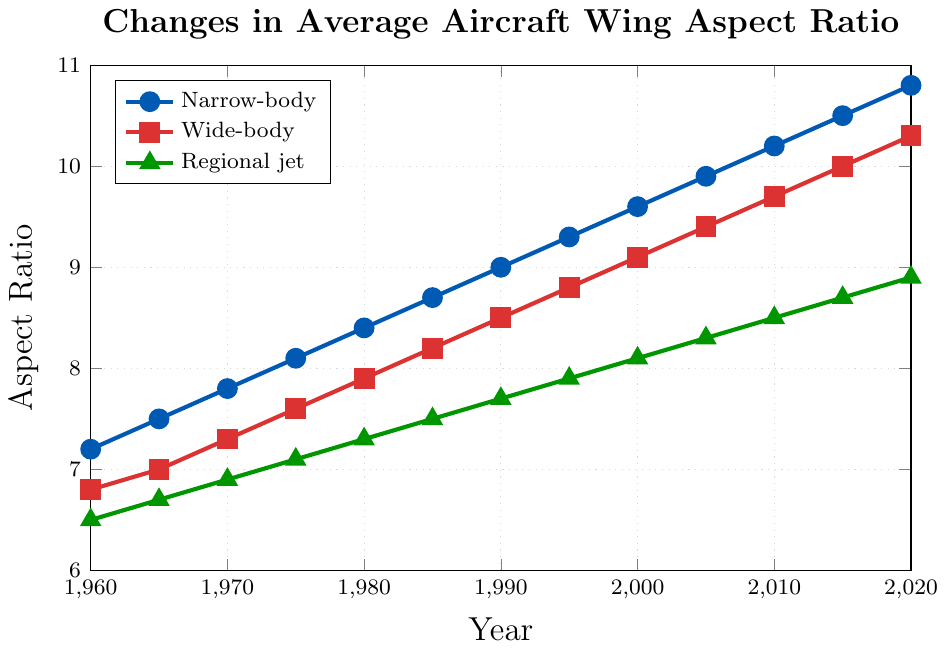What year did the narrow-body planes first reach an aspect ratio of 9.0? Identify the point at which the narrow-body line first crosses 9.0 on the y-axis. This occurs at the year 1990.
Answer: 1990 By how much did the aspect ratio of regional jets increase from 1960 to 2020? Subtract the 1960 aspect ratio of regional jets (6.5) from the 2020 aspect ratio (8.9). (8.9 - 6.5) = 2.4
Answer: 2.4 In what year did all three airplane classes have their aspect ratios equally separated by 0.3 units? Look for a year where the difference between the three classes' aspect ratios are equal to 0.3 units. In 1970, narrow-body (7.8), wide-body (7.3), and regional jets (6.9) have 0.3 units separation between each class.
Answer: 1970 Which airplane class saw the largest increase in average wing aspect ratio between 1960 and 2020? Calculate the difference for each class from 1960 to 2020: Narrow-body (10.8 - 7.2 = 3.6), Wide-body (10.3 - 6.8 = 3.5), Regional jet (8.9 - 6.5 = 2.4). The narrow-body class saw the largest increase of 3.6.
Answer: Narrow-body What pattern do you notice in the trend of wide-body airplane aspect ratios over time? Observe the increase in aspect ratio: It rises steadily from 6.8 in 1960 to 10.3 in 2020 with a consistent upward trend.
Answer: Steady increase In which year did the narrow-body plane's aspect ratio surpass the wide-body's ratio for the first time? Locate the year when the narrow-body line crosses above the wide-body line. This occurs first at 1965.
Answer: 1965 What was the aspect ratio for narrow-body and wide-body aircraft in the year 1985? Identify the aspect ratio on the y-axis at the point corresponding to 1985 for narrow-body (8.7) and wide-body (8.2).
Answer: 8.7 for narrow-body, 8.2 for wide-body How would you describe the overall trend for regional jets from 1960 to 2020? Look at the progression of regional jets on the plot: An almost linear increase from 6.5 in 1960 to 8.9 in 2020.
Answer: Almost linear increase How much higher is the narrow-body aspect ratio compared to the wide-body aspect ratio in 2020? Subtract the wide-body aspect ratio in 2020 (10.3) from the narrow-body aspect ratio (10.8). (10.8 - 10.3) = 0.5
Answer: 0.5 Estimate the average aspect ratio of narrow-body aircraft over the decades shown. Add the aspect ratios for narrow-body aircraft from each decade and divide by the number of data points (7.2+7.5+7.8+8.1+8.4+8.7+9.0+9.3+9.6+9.9+10.2+10.5+10.8)/13 ≈ 9.0
Answer: 9.0 